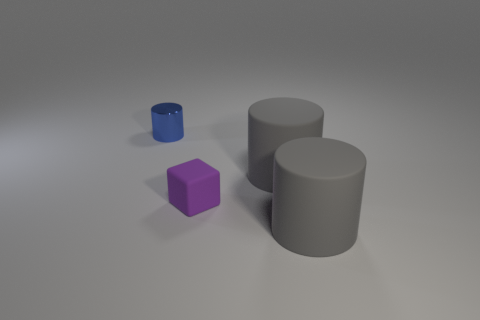How many spheres are blue rubber objects or tiny purple rubber objects?
Provide a short and direct response. 0. Do the purple matte block and the blue thing to the left of the purple matte thing have the same size?
Provide a short and direct response. Yes. Are there more big gray matte things that are behind the purple object than gray blocks?
Offer a very short reply. Yes. How many objects are either big matte cylinders or tiny things that are right of the small shiny thing?
Make the answer very short. 3. Is the number of metallic cylinders greater than the number of big red objects?
Keep it short and to the point. Yes. Are there any gray things that have the same material as the small purple cube?
Offer a very short reply. Yes. The thing that is behind the purple thing and right of the shiny cylinder has what shape?
Keep it short and to the point. Cylinder. How many other objects are the same shape as the small blue metal object?
Ensure brevity in your answer.  2. What number of objects are either purple rubber things or large rubber objects?
Give a very brief answer. 3. There is a gray rubber cylinder in front of the small matte block; what size is it?
Keep it short and to the point. Large. 